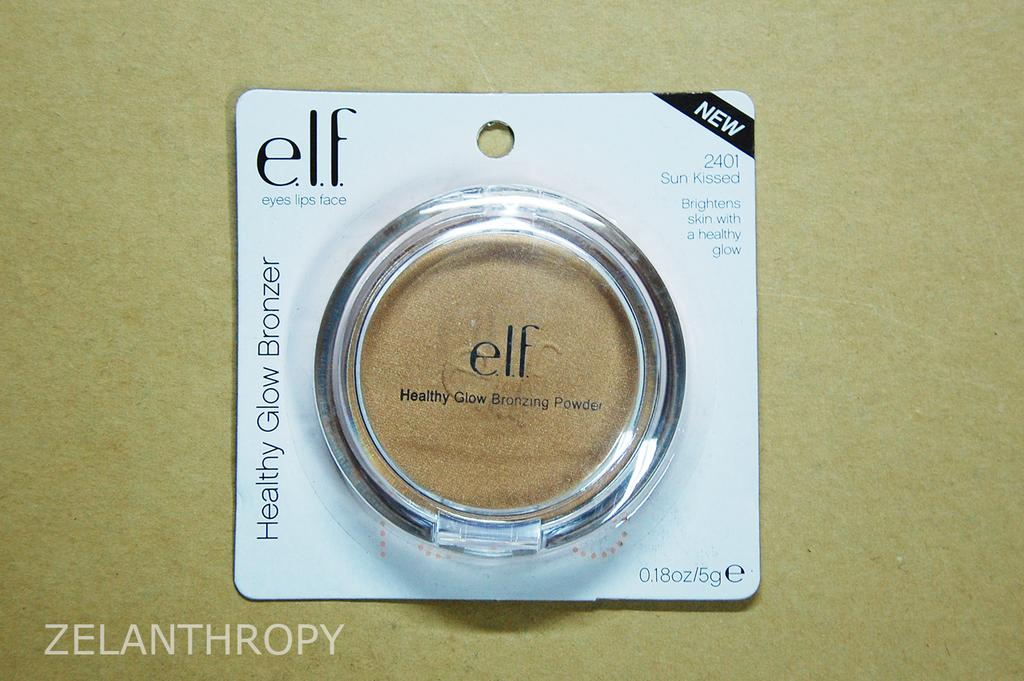Provide a one-sentence caption for the provided image. A small round.Elf brand makeup container with makeup included. 